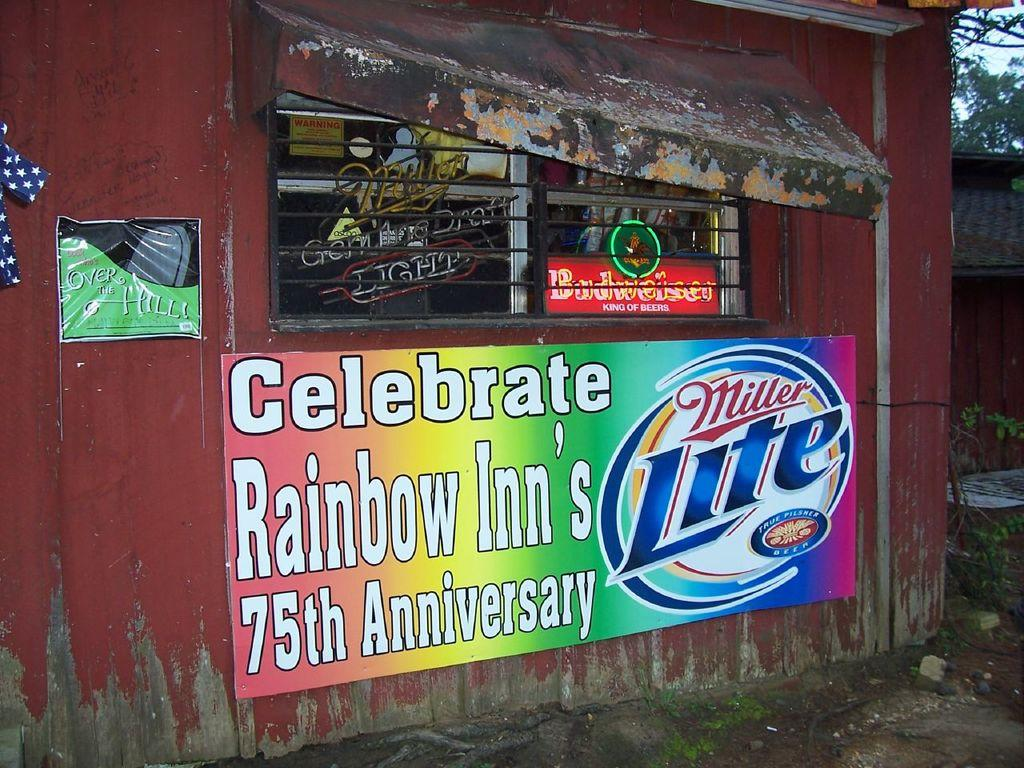Provide a one-sentence caption for the provided image. a closed corner store with Miller Lite ad saying Celebrate Rainbow Inn's 75th anniversary. 